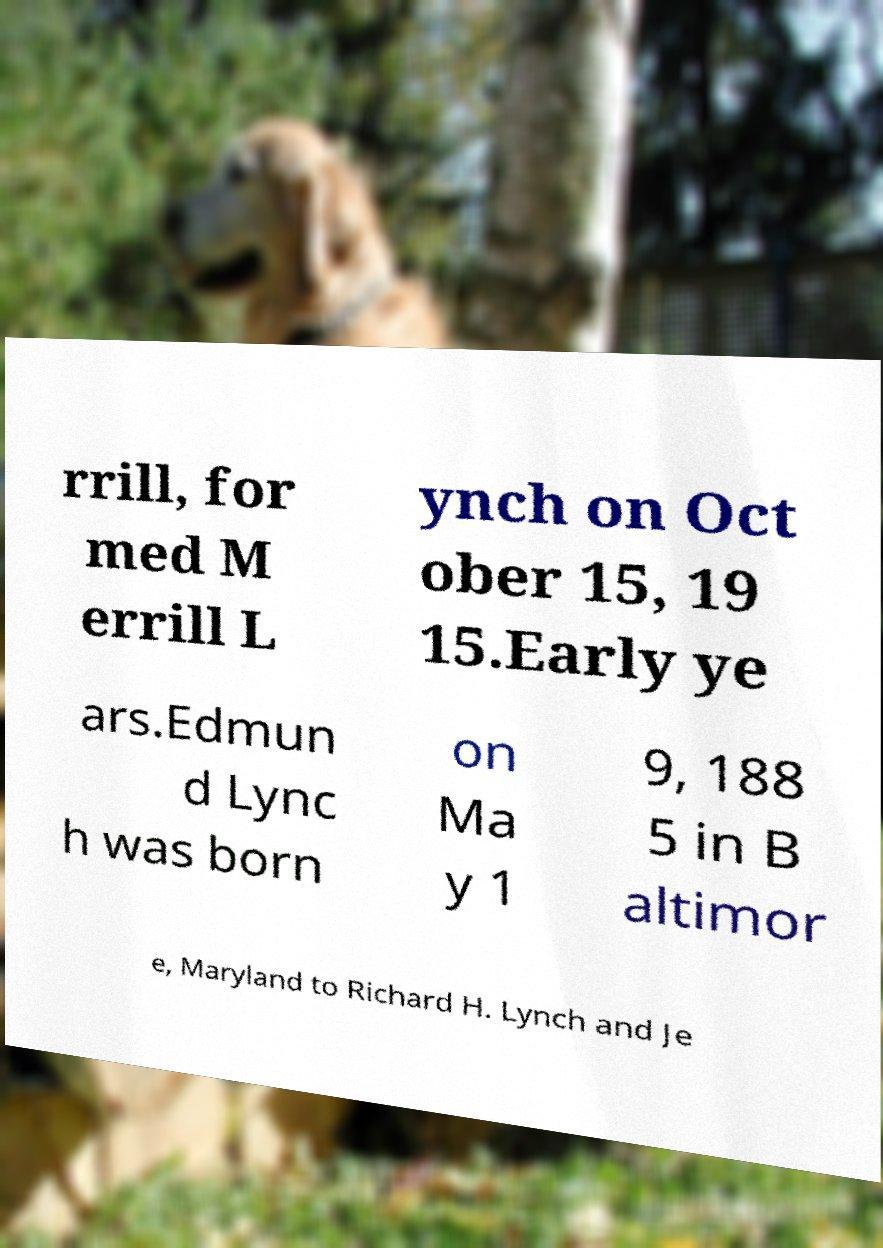Could you extract and type out the text from this image? rrill, for med M errill L ynch on Oct ober 15, 19 15.Early ye ars.Edmun d Lync h was born on Ma y 1 9, 188 5 in B altimor e, Maryland to Richard H. Lynch and Je 